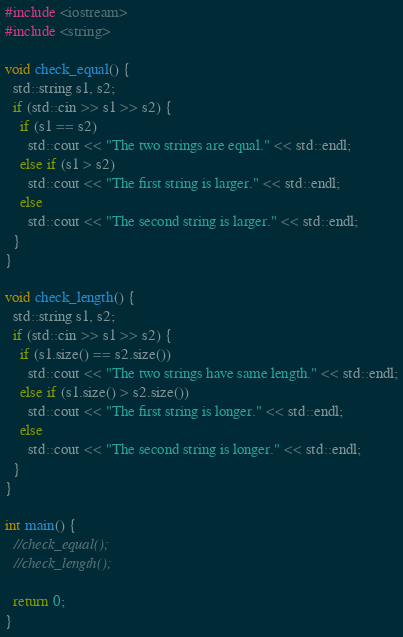Convert code to text. <code><loc_0><loc_0><loc_500><loc_500><_C++_>#include <iostream>
#include <string>

void check_equal() {
  std::string s1, s2;
  if (std::cin >> s1 >> s2) {
    if (s1 == s2)
      std::cout << "The two strings are equal." << std::endl;
    else if (s1 > s2)
      std::cout << "The first string is larger." << std::endl;
    else
      std::cout << "The second string is larger." << std::endl;
  }
}

void check_length() {
  std::string s1, s2;
  if (std::cin >> s1 >> s2) {
    if (s1.size() == s2.size())
      std::cout << "The two strings have same length." << std::endl;
    else if (s1.size() > s2.size())
      std::cout << "The first string is longer." << std::endl;
    else
      std::cout << "The second string is longer." << std::endl;
  }
}

int main() {
  //check_equal();
  //check_length();

  return 0;
}
</code> 